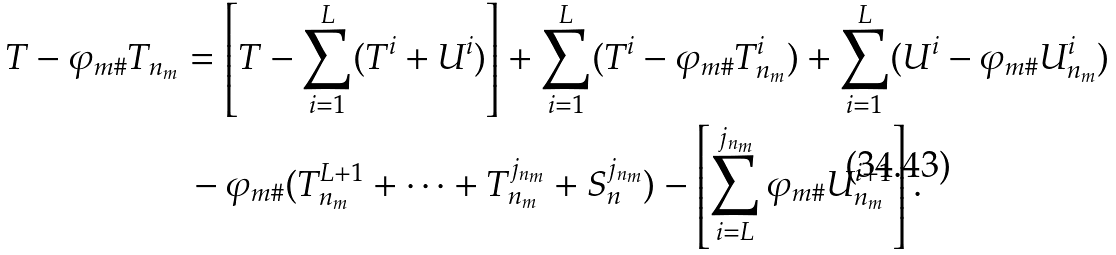Convert formula to latex. <formula><loc_0><loc_0><loc_500><loc_500>T - \varphi _ { m \# } T _ { n _ { m } } & = \left [ T - \sum _ { i = 1 } ^ { L } ( T ^ { i } + U ^ { i } ) \right ] + \sum _ { i = 1 } ^ { L } ( T ^ { i } - \varphi _ { m \# } T _ { n _ { m } } ^ { i } ) + \sum _ { i = 1 } ^ { L } ( U ^ { i } - \varphi _ { m \# } U _ { n _ { m } } ^ { i } ) \\ & \, - \varphi _ { m \# } ( T _ { n _ { m } } ^ { L + 1 } + \dots + T _ { n _ { m } } ^ { j _ { n _ { m } } } + S _ { n } ^ { j _ { n _ { m } } } ) - \left [ \sum _ { i = L } ^ { j _ { n _ { m } } } \varphi _ { m \# } U _ { n _ { m } } ^ { i + 1 } \right ] .</formula> 